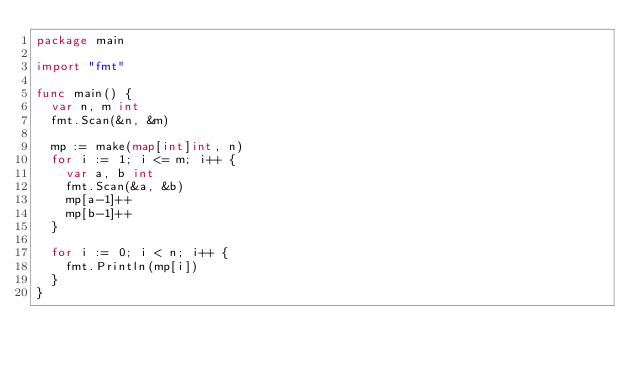Convert code to text. <code><loc_0><loc_0><loc_500><loc_500><_Go_>package main

import "fmt"

func main() {
	var n, m int
	fmt.Scan(&n, &m)

	mp := make(map[int]int, n)
	for i := 1; i <= m; i++ {
		var a, b int
		fmt.Scan(&a, &b)
		mp[a-1]++
		mp[b-1]++
	}

	for i := 0; i < n; i++ {
		fmt.Println(mp[i])
	}
}
</code> 